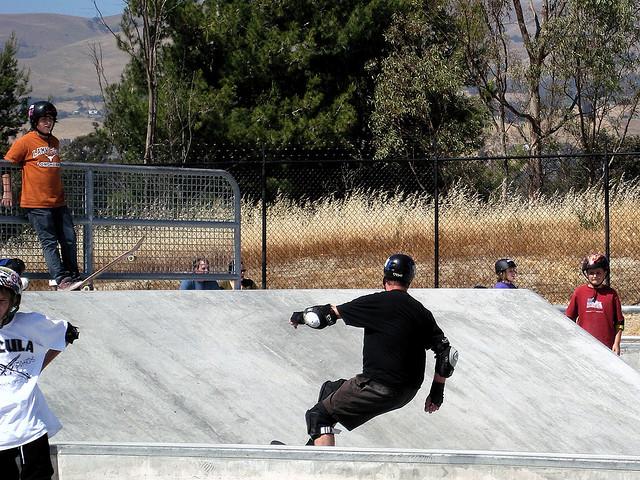What sport are they playing?
Write a very short answer. Skateboarding. What color are the leaves on the trees?
Write a very short answer. Green. How many people are wearing red?
Answer briefly. 1. Where are the people in the picture?
Be succinct. Skate park. 